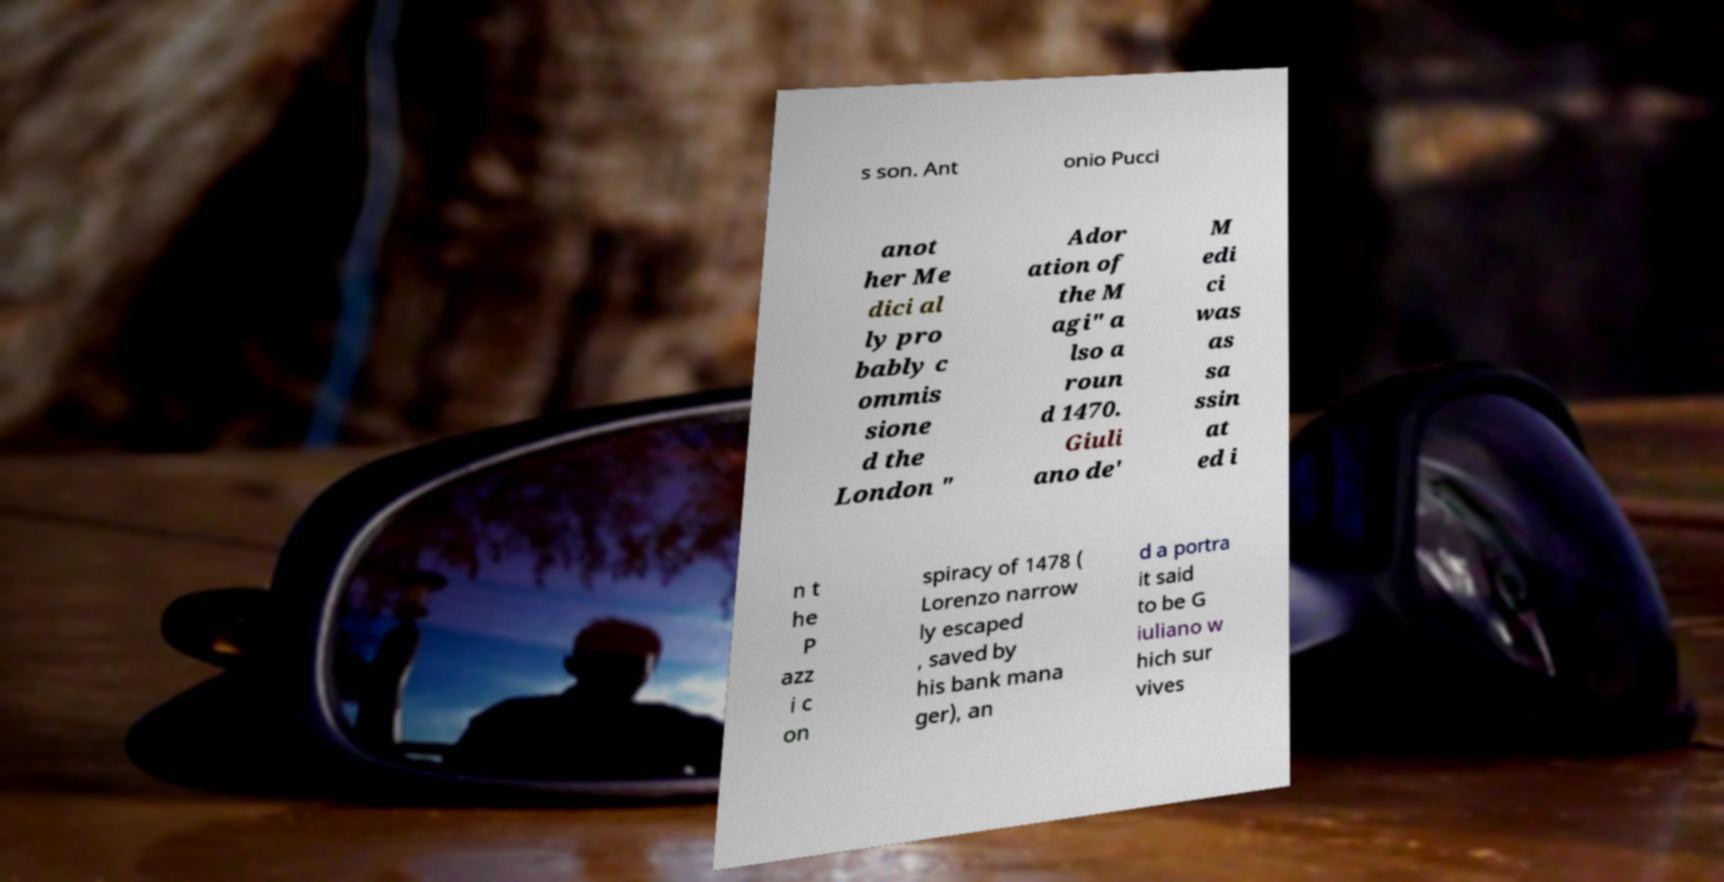Please read and relay the text visible in this image. What does it say? s son. Ant onio Pucci anot her Me dici al ly pro bably c ommis sione d the London " Ador ation of the M agi" a lso a roun d 1470. Giuli ano de' M edi ci was as sa ssin at ed i n t he P azz i c on spiracy of 1478 ( Lorenzo narrow ly escaped , saved by his bank mana ger), an d a portra it said to be G iuliano w hich sur vives 